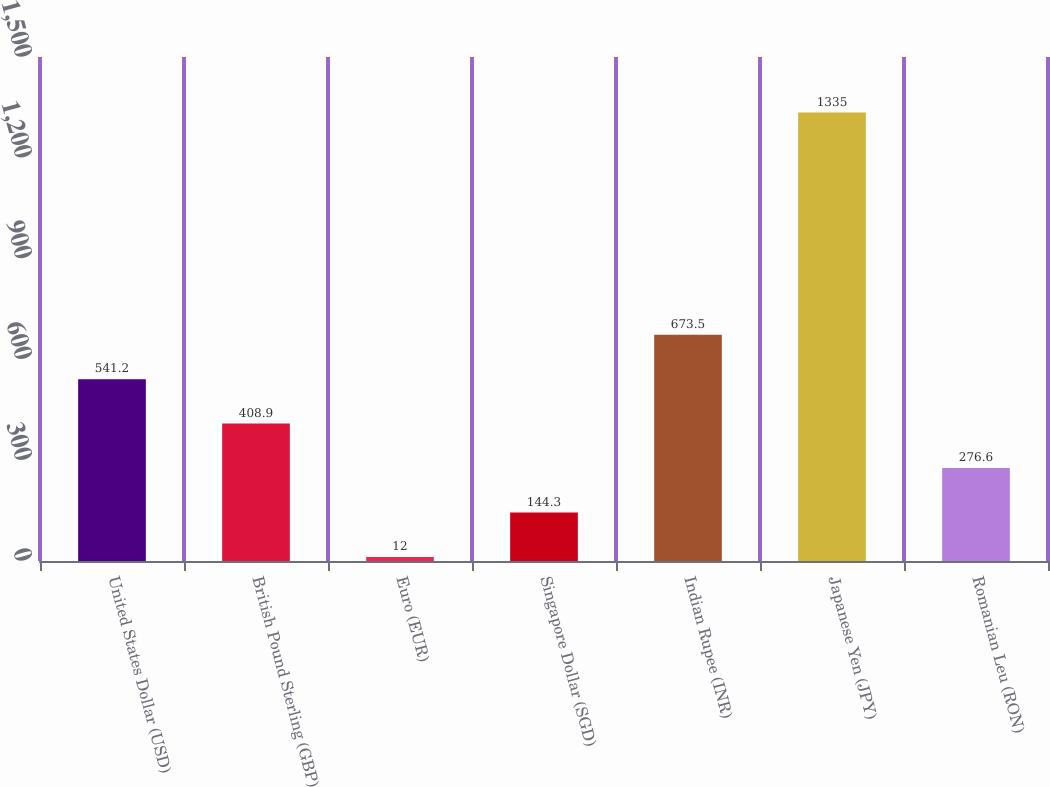Convert chart to OTSL. <chart><loc_0><loc_0><loc_500><loc_500><bar_chart><fcel>United States Dollar (USD)<fcel>British Pound Sterling (GBP)<fcel>Euro (EUR)<fcel>Singapore Dollar (SGD)<fcel>Indian Rupee (INR)<fcel>Japanese Yen (JPY)<fcel>Romanian Leu (RON)<nl><fcel>541.2<fcel>408.9<fcel>12<fcel>144.3<fcel>673.5<fcel>1335<fcel>276.6<nl></chart> 